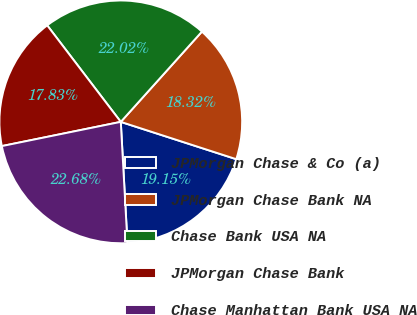Convert chart. <chart><loc_0><loc_0><loc_500><loc_500><pie_chart><fcel>JPMorgan Chase & Co (a)<fcel>JPMorgan Chase Bank NA<fcel>Chase Bank USA NA<fcel>JPMorgan Chase Bank<fcel>Chase Manhattan Bank USA NA<nl><fcel>19.15%<fcel>18.32%<fcel>22.02%<fcel>17.83%<fcel>22.68%<nl></chart> 